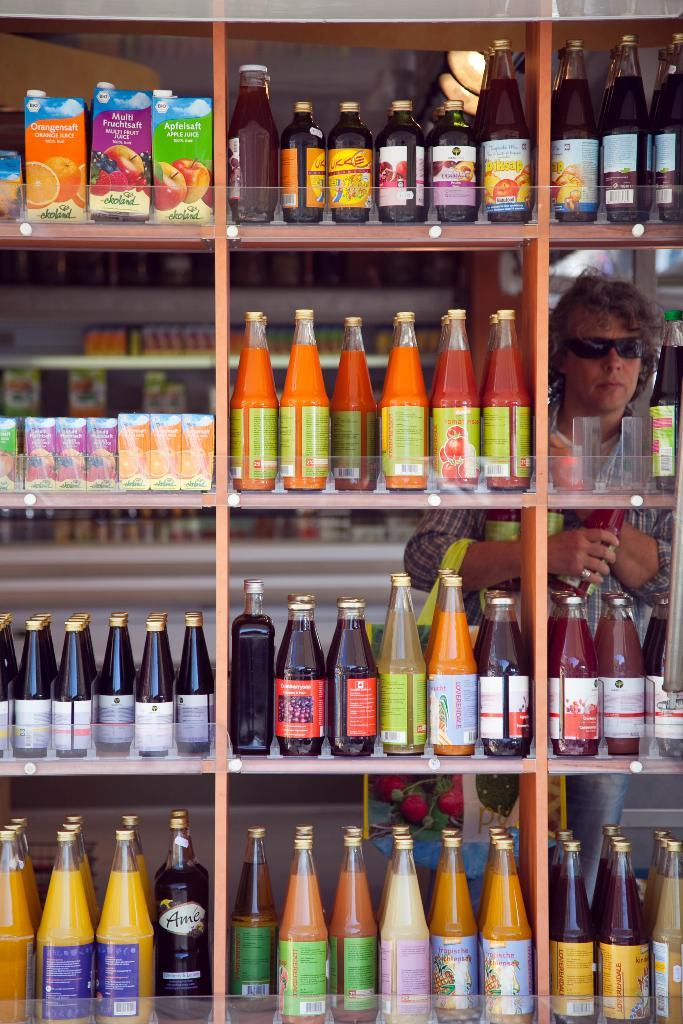Where was the image taken? The image was taken in a store. What can be seen in the background of the image? There is a man standing behind a rack. What is on the rack in the image? The rack contains many bottles. What types of products are in the bottles? The bottles appear to be fruit juices and sauce. Can you see a tent in the image? No, there is no tent present in the image. What color is the man's eye in the image? The image does not show the man's eye, so we cannot determine its color. 